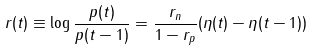Convert formula to latex. <formula><loc_0><loc_0><loc_500><loc_500>r ( t ) \equiv \log \frac { p ( t ) } { p ( t - 1 ) } = \frac { r _ { n } } { 1 - r _ { p } } ( \eta ( t ) - \eta ( t - 1 ) )</formula> 